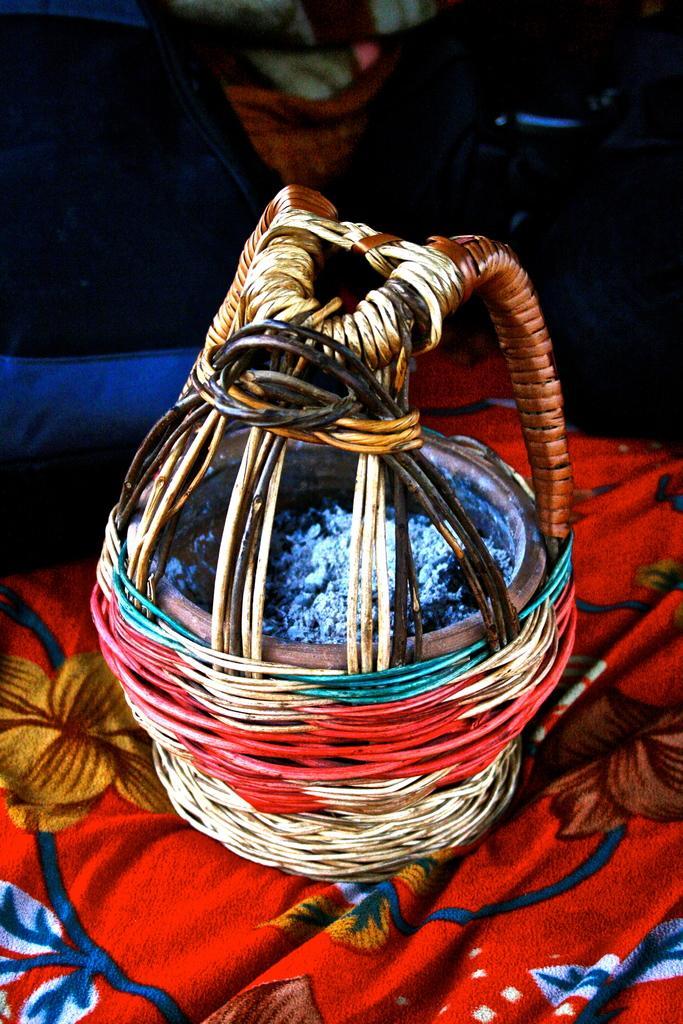In one or two sentences, can you explain what this image depicts? Here we can see a basket with some item in it on a cloth. In the background the image is not clear but we can see a cloth and other objects. 